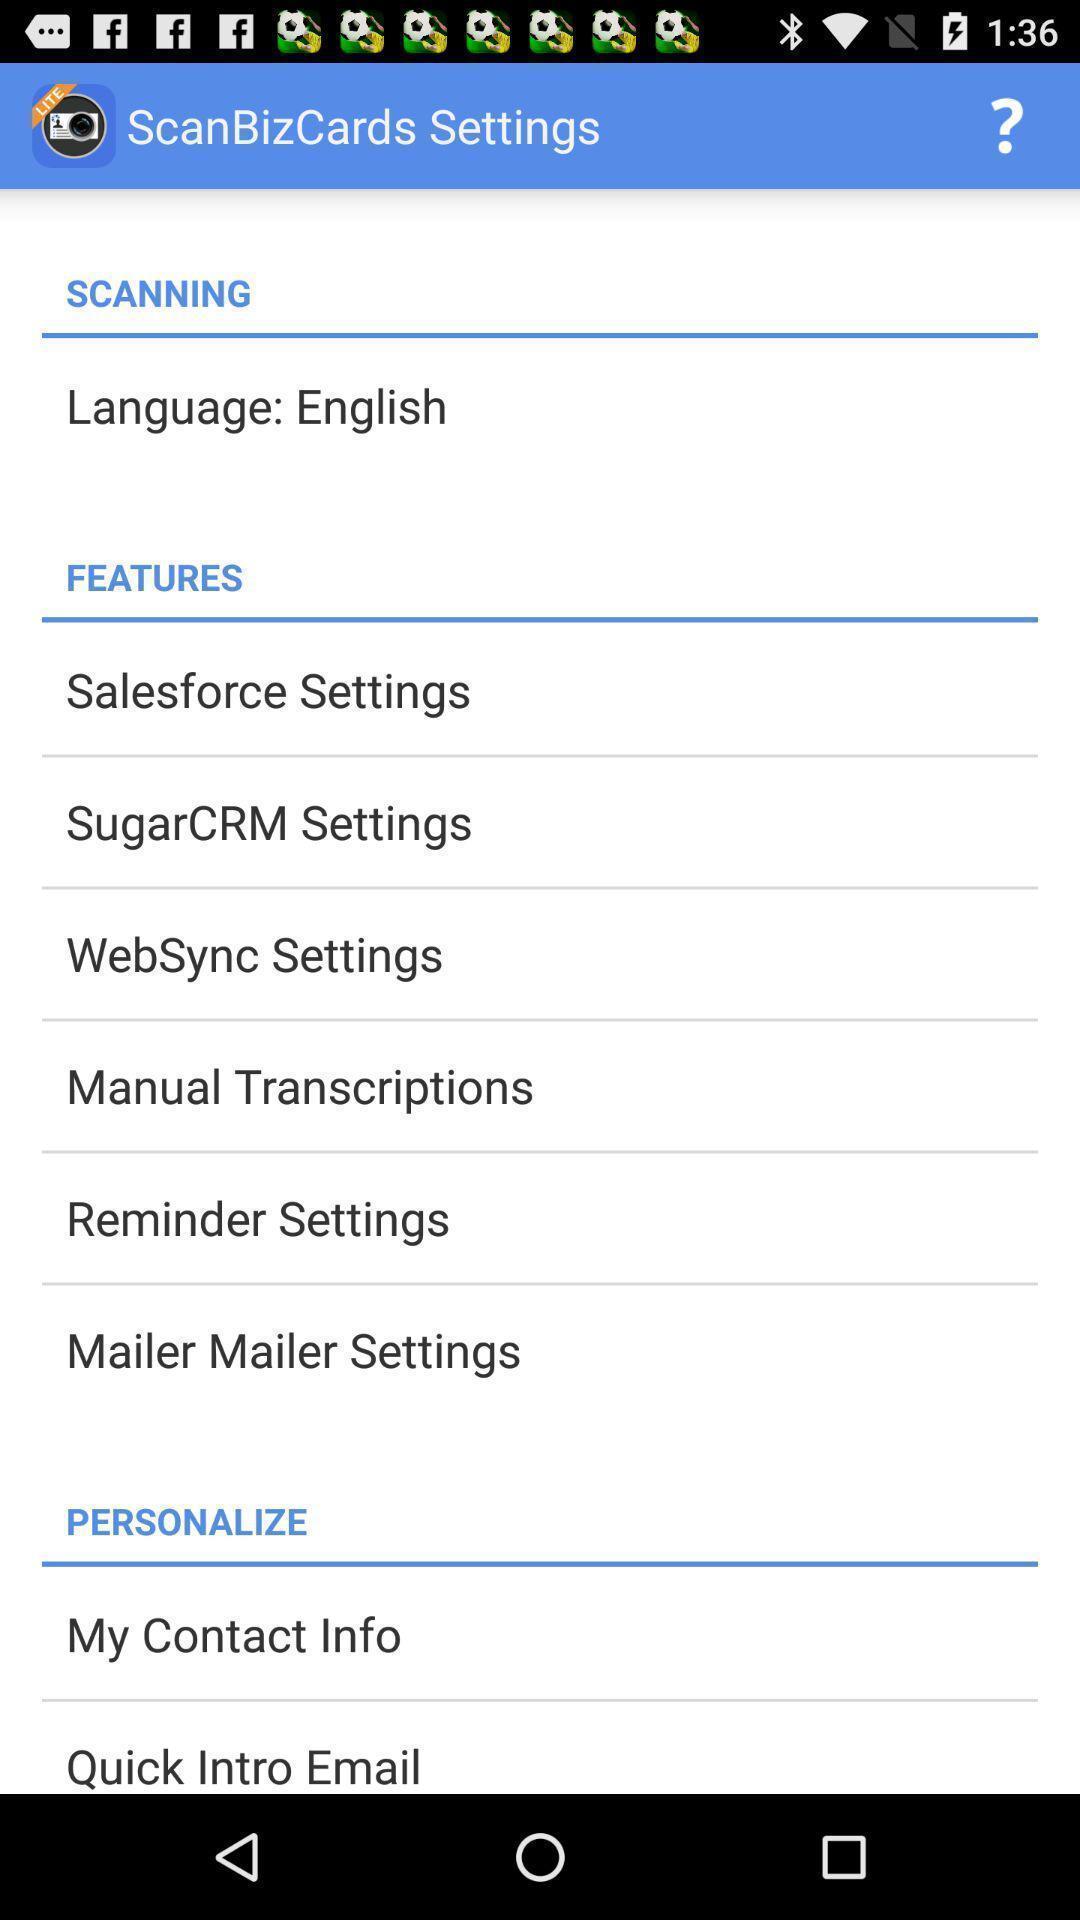What can you discern from this picture? Screen displaying features. 